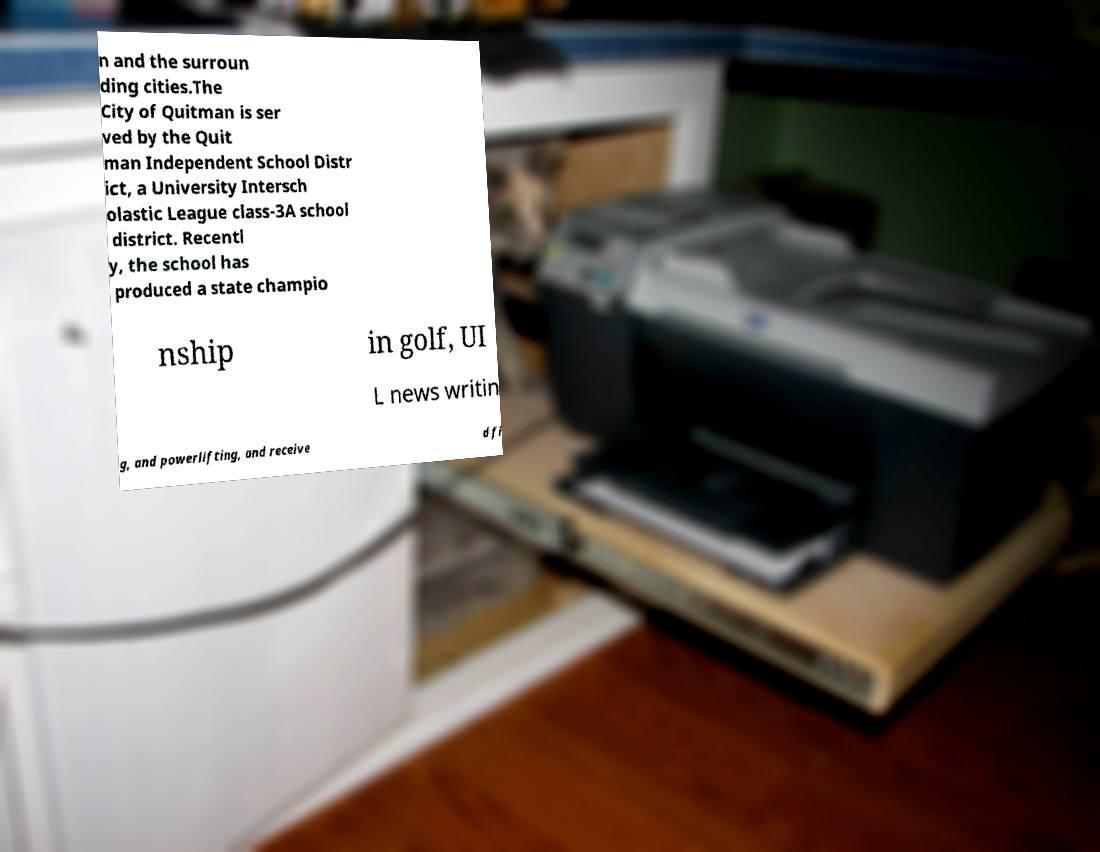For documentation purposes, I need the text within this image transcribed. Could you provide that? n and the surroun ding cities.The City of Quitman is ser ved by the Quit man Independent School Distr ict, a University Intersch olastic League class-3A school district. Recentl y, the school has produced a state champio nship in golf, UI L news writin g, and powerlifting, and receive d fi 